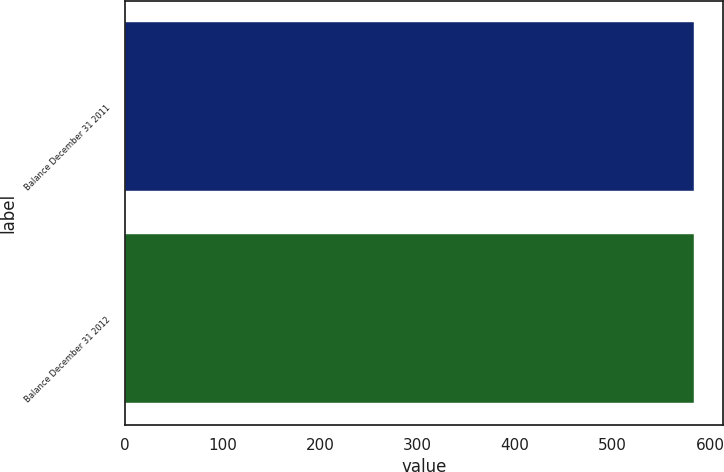<chart> <loc_0><loc_0><loc_500><loc_500><bar_chart><fcel>Balance December 31 2011<fcel>Balance December 31 2012<nl><fcel>584<fcel>584.1<nl></chart> 